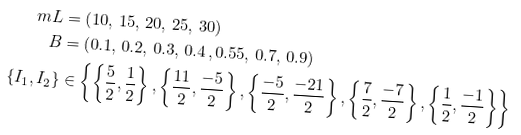Convert formula to latex. <formula><loc_0><loc_0><loc_500><loc_500>m L & = \left ( 1 0 , \, 1 5 , \, 2 0 , \, 2 5 , \, 3 0 \right ) \\ B & = \left ( 0 . 1 , \, 0 . 2 , \, 0 . 3 , \, 0 . 4 \, , 0 . 5 5 , \, 0 . 7 , \, 0 . 9 \right ) \\ \left \{ I _ { 1 } , I _ { 2 } \right \} & \in \left \{ \left \{ \frac { 5 } { 2 } , \frac { 1 } { 2 } \right \} , \left \{ \frac { 1 1 } { 2 } , \frac { - 5 } { 2 } \right \} , \left \{ \frac { - 5 } { 2 } , \frac { - 2 1 } { 2 } \right \} , \left \{ \frac { 7 } { 2 } , \frac { - 7 } { 2 } \right \} , \left \{ \frac { 1 } { 2 } , \frac { - 1 } { 2 } \right \} \right \}</formula> 